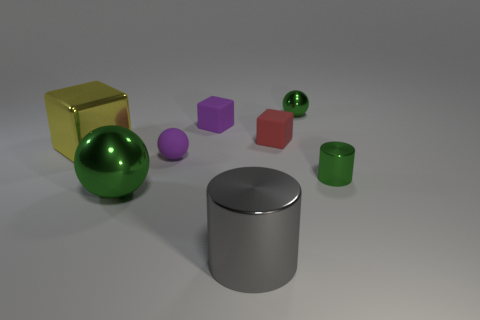The gray shiny thing that is the same size as the yellow metal object is what shape?
Offer a very short reply. Cylinder. What number of other things are the same color as the big ball?
Your response must be concise. 2. There is a ball that is behind the red matte thing that is behind the yellow metallic block; what size is it?
Provide a succinct answer. Small. Do the cylinder that is in front of the big green metal ball and the yellow thing have the same material?
Give a very brief answer. Yes. What shape is the gray object left of the small green cylinder?
Offer a terse response. Cylinder. What number of green cylinders have the same size as the red object?
Keep it short and to the point. 1. The green cylinder is what size?
Ensure brevity in your answer.  Small. What number of shiny balls are in front of the yellow thing?
Your answer should be very brief. 1. What shape is the large gray thing that is the same material as the large green object?
Keep it short and to the point. Cylinder. Is the number of red objects that are on the left side of the small rubber ball less than the number of small cylinders in front of the gray metallic object?
Keep it short and to the point. No. 